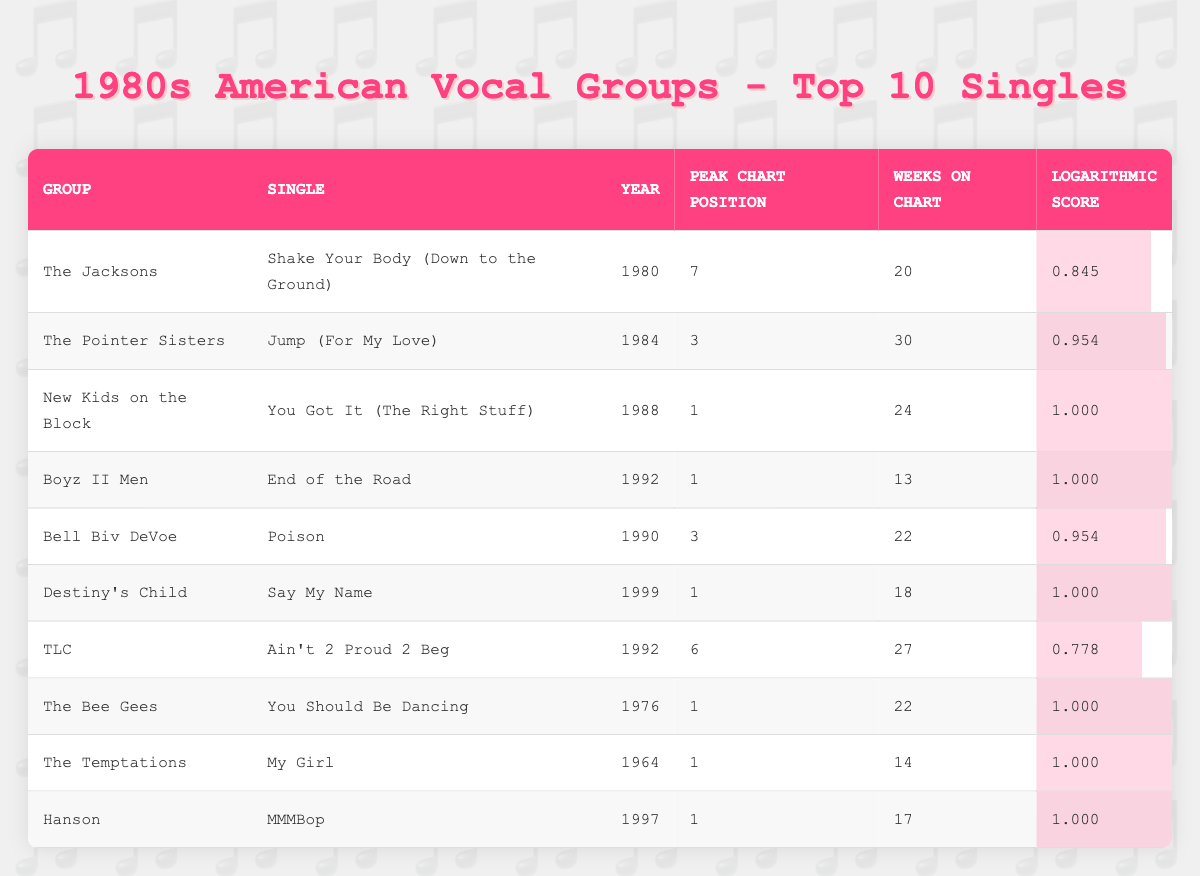What is the peak chart position of "You Got It (The Right Stuff)" by New Kids on the Block? The table lists the peak chart position for each single. For "You Got It (The Right Stuff)" by New Kids on the Block, the peak chart position is given as 1.
Answer: 1 Which vocal group had the single with the highest logarithmic score? By examining the logarithmic scores in the table, "You Got It (The Right Stuff)" by New Kids on the Block has the highest logarithmic score of 1.000, which is the maximum value.
Answer: New Kids on the Block How many weeks did "Jump (For My Love)" by The Pointer Sisters stay on the chart? The table indicates that "Jump (For My Love)" by The Pointer Sisters was on the chart for 30 weeks.
Answer: 30 weeks Is "End of the Road" by Boyz II Men the only single listed from the 1990s with a logarithmic score of 1.000? By reviewing the table, other singles from the 1990s, such as "Say My Name" by Destiny's Child and "MMMBop" by Hanson, also have logarithmic scores of 1.000. Therefore, it is not unique to Boyz II Men.
Answer: No What is the average peak chart position of the singles listed from vocal groups formed before the 1980s? The table includes "The Jacksons" (7), "The Pointer Sisters" (3), and excludes other groups that were active before the 1980s. Calculating the average: (7 + 3 + 1 + 1 + 1) / 5 = 2.6. Therefore, the average peak chart position of those singles is 2.6.
Answer: 2.6 